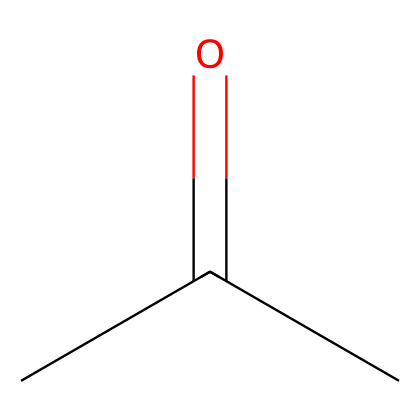What is the common name for this chemical? The chemical with the SMILES CC(=O)C is commonly known as acetone, which is identified by the presence of the ketone functional group (C=O) and its specific carbon chain structure.
Answer: acetone How many carbon atoms are in this molecule? The provided SMILES representation indicates that there are three carbon atoms present in the structure (C-C-C), as each 'C' represents a carbon atom.
Answer: three What type of functional group is present in acetone? In the provided SMILES, the part '(=O)' indicates the presence of a carbonyl functional group, specifically a ketone, due to the arrangement of the oxygen double-bonded to a carbon atom while being flanked by two carbon atoms.
Answer: ketone What is the total number of hydrogen atoms in this molecule? To determine the number of hydrogen atoms, we count the saturation of the carbon atoms in acetone. Each carbon typically bonds with enough hydrogens to satisfy tetravalency, resulting in three potential bonds from the two terminal carbon atoms and one from the central carbon. In total, there are six hydrogen atoms.
Answer: six What are the primary environmental implications of using acetone in nail polish removers? Acetone is volatile and can contribute to air pollution as it evaporates quickly, leading to potential respiratory issues and environmental degradation. Additionally, its production and disposal carry risks of water contamination.
Answer: air pollution How does the presence of the carbonyl group affect acetone's polarity? The carbonyl group (C=O) is polar due to the electronegativity difference between carbon and oxygen, leading to a partial negative charge on oxygen and a partial positive charge on carbon, making acetone a polar solvent.
Answer: polar solvent 